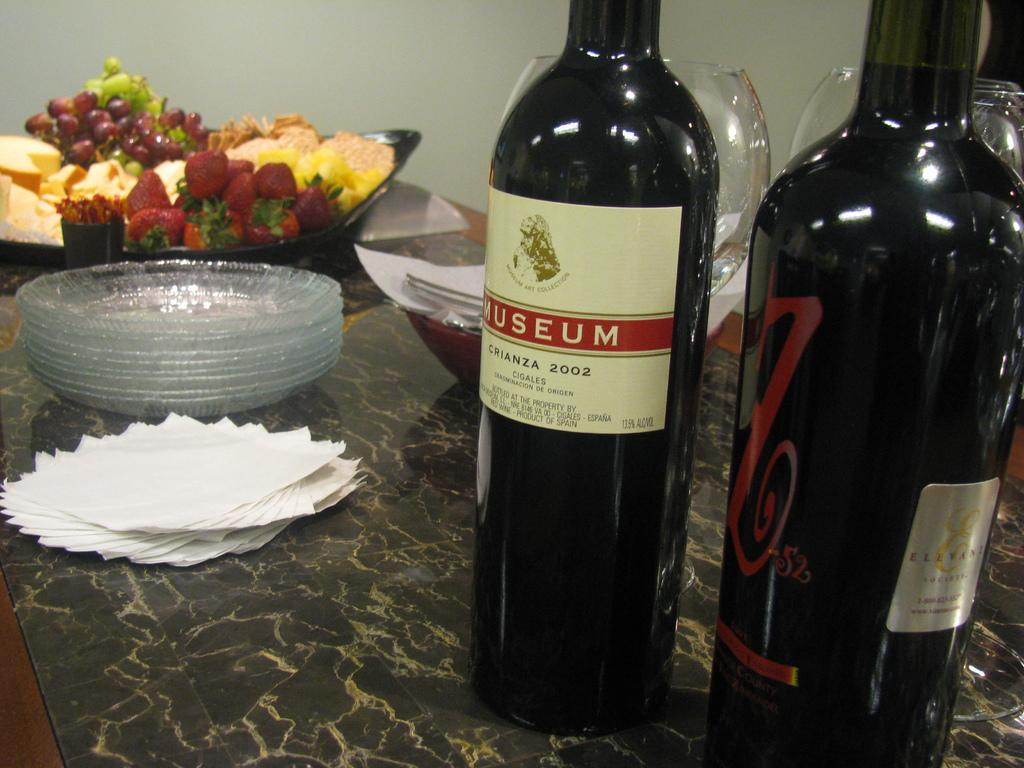What is the main piece of furniture in the image? There is a table in the image. What type of beverages are present on the table? There are two wine bottles on the table. What type of glassware is on the table? There are wine glasses on the table. What type of dishware is on the table? There are plates on the table. What type of paper product is on the table? There are tissue papers on the table. What type of container with food items is on the table? There is a bowl with food items on the table. How does the drain affect the wine glasses on the table? There is no drain present in the image, so it cannot affect the wine glasses. 